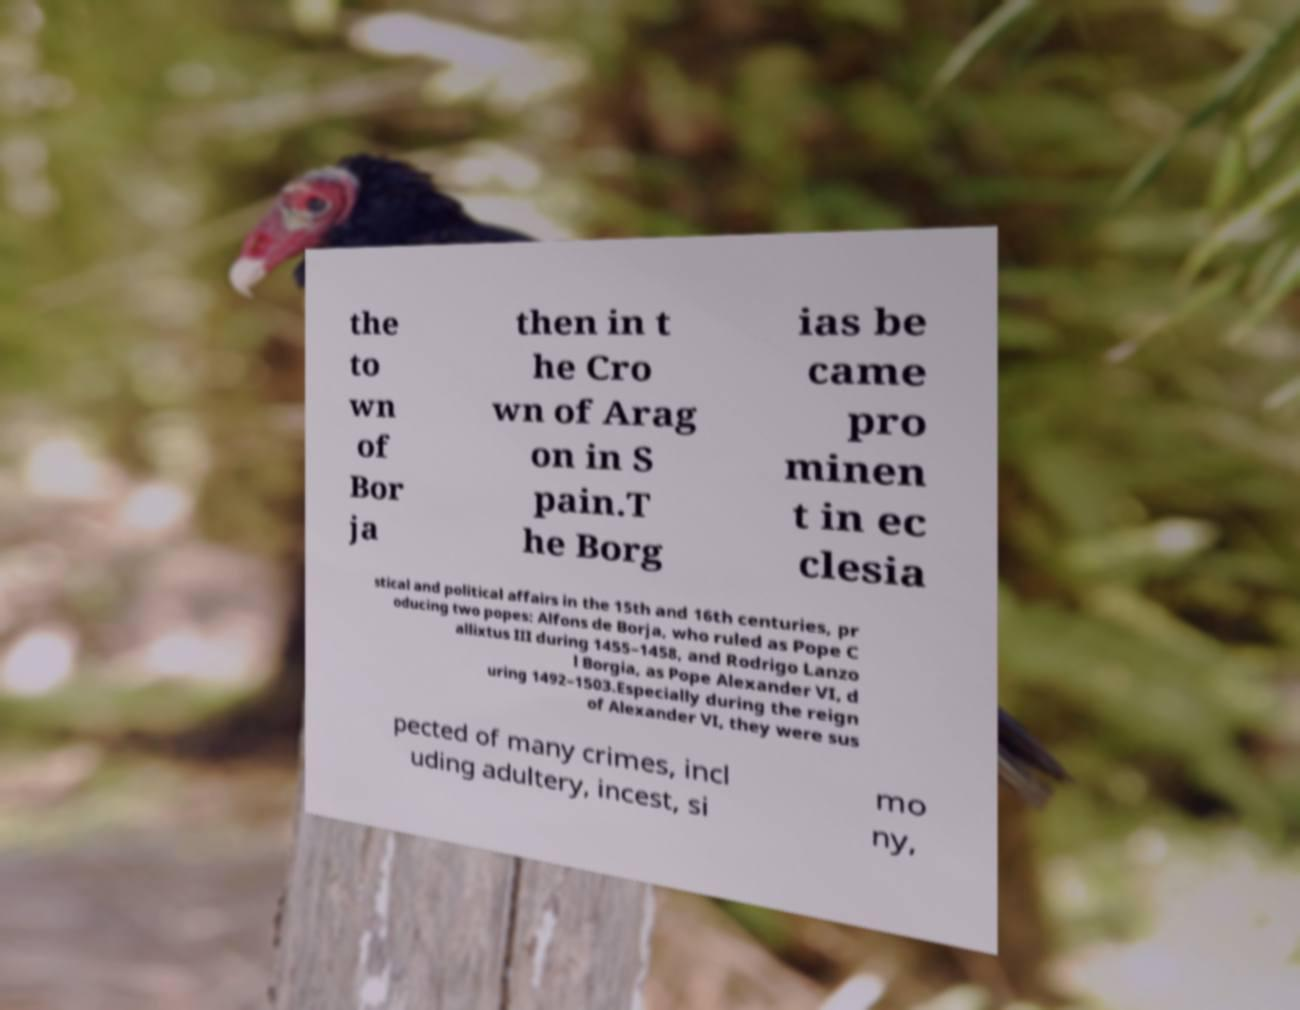Can you accurately transcribe the text from the provided image for me? the to wn of Bor ja then in t he Cro wn of Arag on in S pain.T he Borg ias be came pro minen t in ec clesia stical and political affairs in the 15th and 16th centuries, pr oducing two popes: Alfons de Borja, who ruled as Pope C allixtus III during 1455–1458, and Rodrigo Lanzo l Borgia, as Pope Alexander VI, d uring 1492–1503.Especially during the reign of Alexander VI, they were sus pected of many crimes, incl uding adultery, incest, si mo ny, 